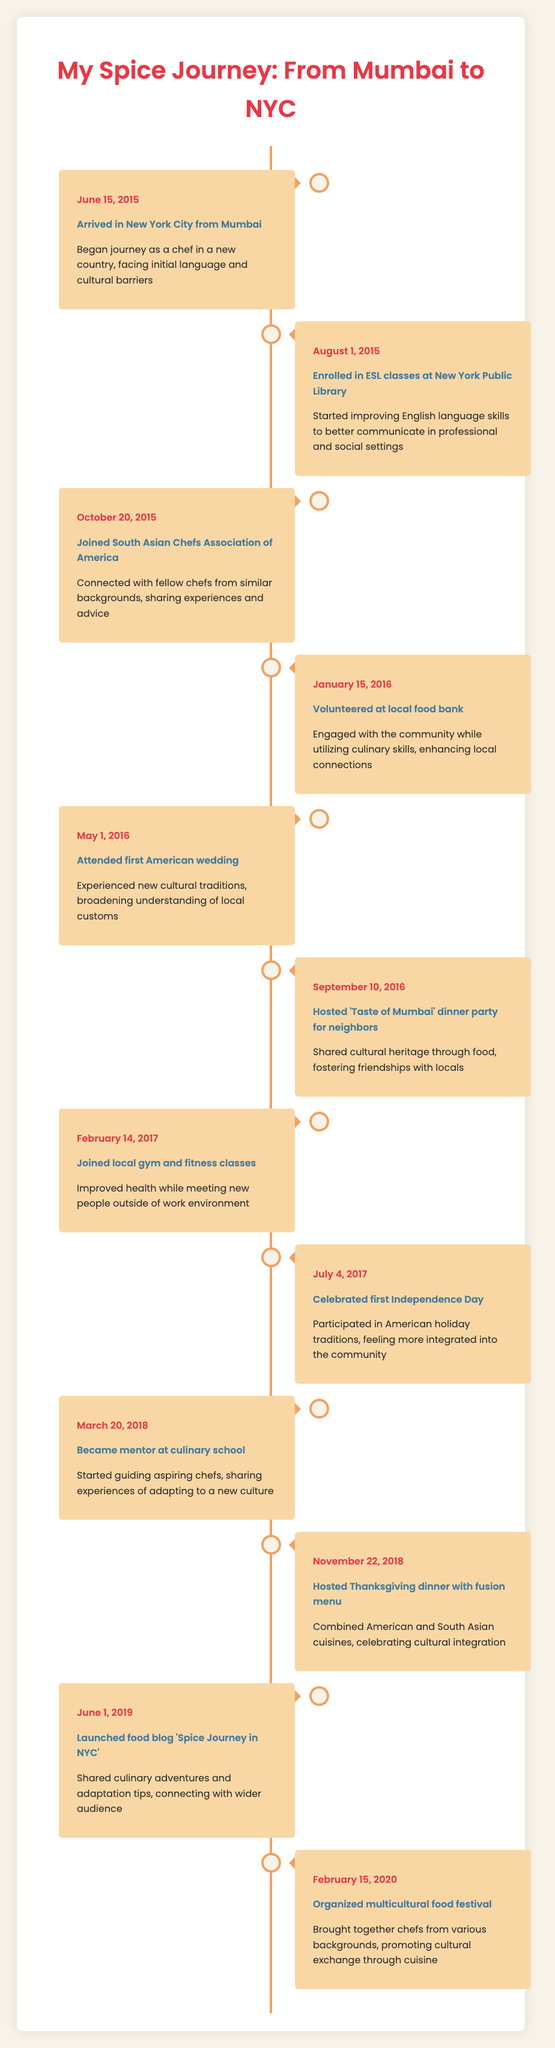What date did you arrive in New York City? The table indicates that I arrived on June 15, 2015.
Answer: June 15, 2015 How many events occurred in 2016? Upon scanning the table, I find five distinct events listed for the year 2016: January 15, May 1, September 10, and two events on October 20.
Answer: Five events Did I participate in any activities related to community engagement in 2016? Yes, the table shows two activities related to community engagement in 2016: volunteering at a local food bank on January 15 and hosting a dinner party on September 10.
Answer: Yes What was the description of the event on February 14, 2017? The entry for February 14, 2017, states that I joined a local gym and fitness classes, focusing on improving health while meeting new people outside of work.
Answer: Joined local gym and fitness classes What are the two events that combined different cultural cuisines? The two events that combined cultural cuisines are: the Thanksgiving dinner with a fusion menu on November 22, 2018, and the organized multicultural food festival on February 15, 2020.
Answer: Thanksgiving dinner and multicultural food festival In which year did I mentor new chefs? Referring to the table, I became a mentor at a culinary school in 2018, as noted on March 20.
Answer: 2018 How many different cultural integration events happened between 2015 and 2018? To find this, I look for events that explicitly mention cultural integration. In the given range, there are four such events: attending an American wedding in 2016, hosting a dinner party in 2016, hosting a Thanksgiving dinner in 2018, and organizing a food festival in 2020.
Answer: Four events When did I start my food blog, and what was its name? The food blog named 'Spice Journey in NYC' was launched on June 1, 2019, according to the timeline.
Answer: June 1, 2019, 'Spice Journey in NYC' Did I celebrate any American holidays during my journey, and if so, which ones? Yes, according to the timeline, I celebrated my first Independence Day on July 4, 2017, which is a significant American holiday.
Answer: Yes, Independence Day 